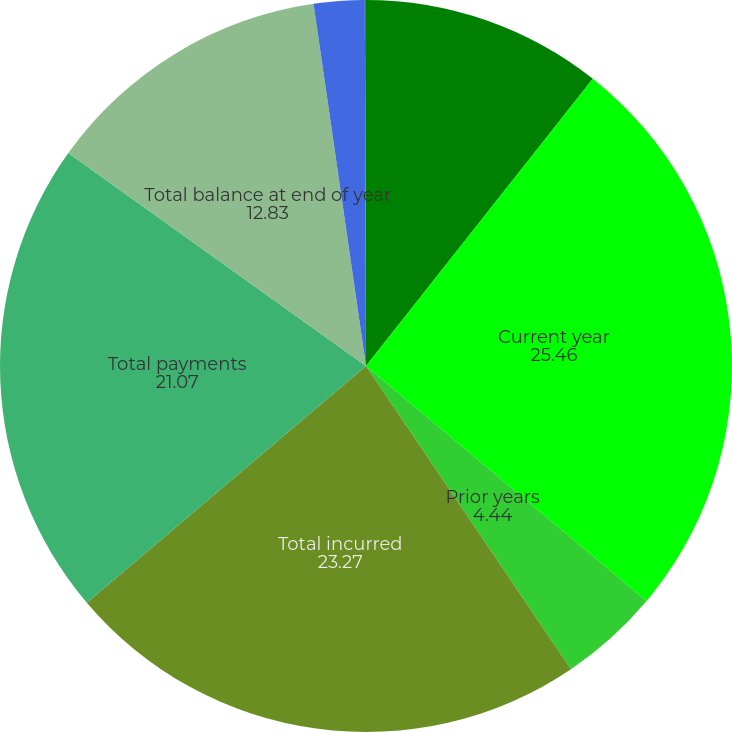Convert chart to OTSL. <chart><loc_0><loc_0><loc_500><loc_500><pie_chart><fcel>Balance at beginning of year<fcel>Current year<fcel>Prior years<fcel>Total incurred<fcel>Total payments<fcel>Total balance at end of year<fcel>Claim adjustment expense<fcel>Reinsurance recoverables<nl><fcel>10.64%<fcel>25.46%<fcel>4.44%<fcel>23.27%<fcel>21.07%<fcel>12.83%<fcel>2.24%<fcel>0.05%<nl></chart> 